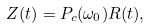<formula> <loc_0><loc_0><loc_500><loc_500>Z ( t ) = P _ { c } ( \omega _ { 0 } ) R ( t ) ,</formula> 